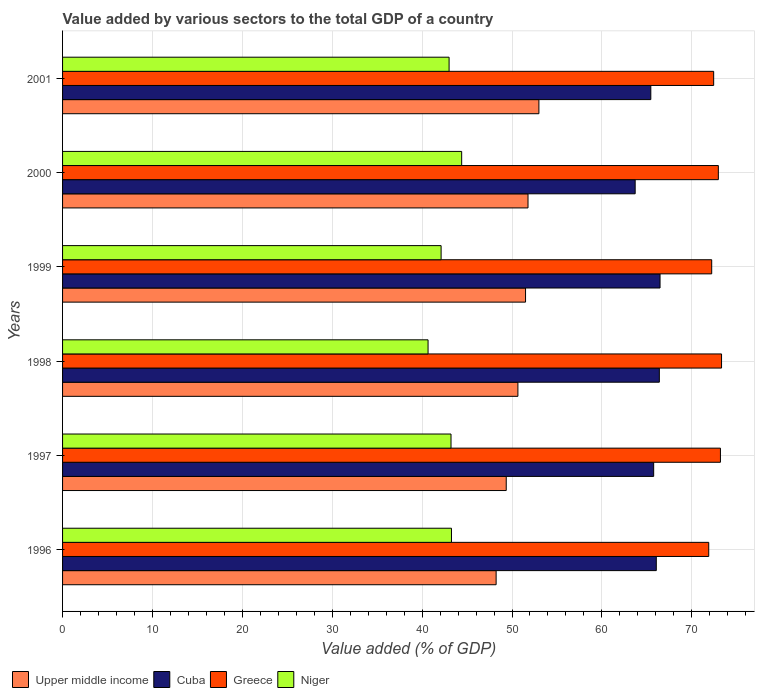How many different coloured bars are there?
Your answer should be compact. 4. Are the number of bars per tick equal to the number of legend labels?
Your answer should be compact. Yes. How many bars are there on the 1st tick from the top?
Your response must be concise. 4. How many bars are there on the 3rd tick from the bottom?
Offer a very short reply. 4. What is the label of the 1st group of bars from the top?
Ensure brevity in your answer.  2001. What is the value added by various sectors to the total GDP in Upper middle income in 1998?
Provide a short and direct response. 50.66. Across all years, what is the maximum value added by various sectors to the total GDP in Cuba?
Make the answer very short. 66.47. Across all years, what is the minimum value added by various sectors to the total GDP in Greece?
Your answer should be compact. 71.89. In which year was the value added by various sectors to the total GDP in Upper middle income minimum?
Give a very brief answer. 1996. What is the total value added by various sectors to the total GDP in Greece in the graph?
Your answer should be compact. 436. What is the difference between the value added by various sectors to the total GDP in Niger in 1998 and that in 2000?
Provide a short and direct response. -3.74. What is the difference between the value added by various sectors to the total GDP in Niger in 1997 and the value added by various sectors to the total GDP in Cuba in 1999?
Offer a terse response. -23.26. What is the average value added by various sectors to the total GDP in Cuba per year?
Your answer should be very brief. 65.64. In the year 1997, what is the difference between the value added by various sectors to the total GDP in Greece and value added by various sectors to the total GDP in Upper middle income?
Your response must be concise. 23.83. What is the ratio of the value added by various sectors to the total GDP in Greece in 1996 to that in 1999?
Ensure brevity in your answer.  1. What is the difference between the highest and the second highest value added by various sectors to the total GDP in Greece?
Keep it short and to the point. 0.12. What is the difference between the highest and the lowest value added by various sectors to the total GDP in Cuba?
Keep it short and to the point. 2.77. Is the sum of the value added by various sectors to the total GDP in Cuba in 1996 and 2001 greater than the maximum value added by various sectors to the total GDP in Niger across all years?
Keep it short and to the point. Yes. Is it the case that in every year, the sum of the value added by various sectors to the total GDP in Niger and value added by various sectors to the total GDP in Upper middle income is greater than the sum of value added by various sectors to the total GDP in Cuba and value added by various sectors to the total GDP in Greece?
Provide a succinct answer. No. What does the 3rd bar from the top in 2001 represents?
Give a very brief answer. Cuba. What does the 1st bar from the bottom in 1998 represents?
Keep it short and to the point. Upper middle income. Is it the case that in every year, the sum of the value added by various sectors to the total GDP in Cuba and value added by various sectors to the total GDP in Upper middle income is greater than the value added by various sectors to the total GDP in Niger?
Your response must be concise. Yes. How many bars are there?
Provide a short and direct response. 24. Does the graph contain grids?
Your response must be concise. Yes. Where does the legend appear in the graph?
Offer a terse response. Bottom left. How are the legend labels stacked?
Offer a terse response. Horizontal. What is the title of the graph?
Your response must be concise. Value added by various sectors to the total GDP of a country. What is the label or title of the X-axis?
Provide a succinct answer. Value added (% of GDP). What is the label or title of the Y-axis?
Offer a terse response. Years. What is the Value added (% of GDP) in Upper middle income in 1996?
Provide a succinct answer. 48.23. What is the Value added (% of GDP) of Cuba in 1996?
Provide a short and direct response. 66.05. What is the Value added (% of GDP) of Greece in 1996?
Provide a short and direct response. 71.89. What is the Value added (% of GDP) in Niger in 1996?
Your response must be concise. 43.27. What is the Value added (% of GDP) in Upper middle income in 1997?
Your response must be concise. 49.36. What is the Value added (% of GDP) of Cuba in 1997?
Offer a very short reply. 65.76. What is the Value added (% of GDP) in Greece in 1997?
Ensure brevity in your answer.  73.19. What is the Value added (% of GDP) of Niger in 1997?
Your answer should be very brief. 43.21. What is the Value added (% of GDP) in Upper middle income in 1998?
Keep it short and to the point. 50.66. What is the Value added (% of GDP) in Cuba in 1998?
Your answer should be compact. 66.39. What is the Value added (% of GDP) of Greece in 1998?
Ensure brevity in your answer.  73.31. What is the Value added (% of GDP) in Niger in 1998?
Give a very brief answer. 40.66. What is the Value added (% of GDP) in Upper middle income in 1999?
Provide a succinct answer. 51.51. What is the Value added (% of GDP) of Cuba in 1999?
Keep it short and to the point. 66.47. What is the Value added (% of GDP) in Greece in 1999?
Offer a very short reply. 72.22. What is the Value added (% of GDP) in Niger in 1999?
Provide a short and direct response. 42.11. What is the Value added (% of GDP) in Upper middle income in 2000?
Ensure brevity in your answer.  51.78. What is the Value added (% of GDP) of Cuba in 2000?
Give a very brief answer. 63.7. What is the Value added (% of GDP) in Greece in 2000?
Ensure brevity in your answer.  72.96. What is the Value added (% of GDP) of Niger in 2000?
Offer a very short reply. 44.4. What is the Value added (% of GDP) of Upper middle income in 2001?
Ensure brevity in your answer.  52.99. What is the Value added (% of GDP) in Cuba in 2001?
Provide a succinct answer. 65.44. What is the Value added (% of GDP) in Greece in 2001?
Provide a succinct answer. 72.44. What is the Value added (% of GDP) in Niger in 2001?
Ensure brevity in your answer.  43. Across all years, what is the maximum Value added (% of GDP) in Upper middle income?
Your response must be concise. 52.99. Across all years, what is the maximum Value added (% of GDP) of Cuba?
Give a very brief answer. 66.47. Across all years, what is the maximum Value added (% of GDP) of Greece?
Give a very brief answer. 73.31. Across all years, what is the maximum Value added (% of GDP) in Niger?
Provide a succinct answer. 44.4. Across all years, what is the minimum Value added (% of GDP) in Upper middle income?
Provide a short and direct response. 48.23. Across all years, what is the minimum Value added (% of GDP) in Cuba?
Make the answer very short. 63.7. Across all years, what is the minimum Value added (% of GDP) of Greece?
Keep it short and to the point. 71.89. Across all years, what is the minimum Value added (% of GDP) in Niger?
Your answer should be very brief. 40.66. What is the total Value added (% of GDP) in Upper middle income in the graph?
Provide a succinct answer. 304.53. What is the total Value added (% of GDP) in Cuba in the graph?
Your answer should be compact. 393.82. What is the total Value added (% of GDP) of Greece in the graph?
Provide a short and direct response. 436. What is the total Value added (% of GDP) in Niger in the graph?
Ensure brevity in your answer.  256.66. What is the difference between the Value added (% of GDP) of Upper middle income in 1996 and that in 1997?
Provide a succinct answer. -1.12. What is the difference between the Value added (% of GDP) of Cuba in 1996 and that in 1997?
Offer a very short reply. 0.29. What is the difference between the Value added (% of GDP) in Greece in 1996 and that in 1997?
Make the answer very short. -1.3. What is the difference between the Value added (% of GDP) in Niger in 1996 and that in 1997?
Ensure brevity in your answer.  0.05. What is the difference between the Value added (% of GDP) of Upper middle income in 1996 and that in 1998?
Your answer should be compact. -2.42. What is the difference between the Value added (% of GDP) of Cuba in 1996 and that in 1998?
Give a very brief answer. -0.34. What is the difference between the Value added (% of GDP) of Greece in 1996 and that in 1998?
Keep it short and to the point. -1.43. What is the difference between the Value added (% of GDP) in Niger in 1996 and that in 1998?
Make the answer very short. 2.6. What is the difference between the Value added (% of GDP) in Upper middle income in 1996 and that in 1999?
Give a very brief answer. -3.27. What is the difference between the Value added (% of GDP) in Cuba in 1996 and that in 1999?
Your answer should be compact. -0.42. What is the difference between the Value added (% of GDP) of Greece in 1996 and that in 1999?
Provide a succinct answer. -0.33. What is the difference between the Value added (% of GDP) in Niger in 1996 and that in 1999?
Offer a very short reply. 1.15. What is the difference between the Value added (% of GDP) of Upper middle income in 1996 and that in 2000?
Your answer should be very brief. -3.55. What is the difference between the Value added (% of GDP) of Cuba in 1996 and that in 2000?
Offer a very short reply. 2.35. What is the difference between the Value added (% of GDP) in Greece in 1996 and that in 2000?
Keep it short and to the point. -1.07. What is the difference between the Value added (% of GDP) of Niger in 1996 and that in 2000?
Keep it short and to the point. -1.13. What is the difference between the Value added (% of GDP) of Upper middle income in 1996 and that in 2001?
Your answer should be compact. -4.76. What is the difference between the Value added (% of GDP) in Cuba in 1996 and that in 2001?
Give a very brief answer. 0.61. What is the difference between the Value added (% of GDP) in Greece in 1996 and that in 2001?
Keep it short and to the point. -0.55. What is the difference between the Value added (% of GDP) in Niger in 1996 and that in 2001?
Give a very brief answer. 0.26. What is the difference between the Value added (% of GDP) of Upper middle income in 1997 and that in 1998?
Give a very brief answer. -1.3. What is the difference between the Value added (% of GDP) in Cuba in 1997 and that in 1998?
Offer a terse response. -0.63. What is the difference between the Value added (% of GDP) in Greece in 1997 and that in 1998?
Make the answer very short. -0.12. What is the difference between the Value added (% of GDP) in Niger in 1997 and that in 1998?
Offer a very short reply. 2.55. What is the difference between the Value added (% of GDP) of Upper middle income in 1997 and that in 1999?
Your answer should be compact. -2.15. What is the difference between the Value added (% of GDP) in Cuba in 1997 and that in 1999?
Offer a terse response. -0.71. What is the difference between the Value added (% of GDP) of Greece in 1997 and that in 1999?
Your response must be concise. 0.97. What is the difference between the Value added (% of GDP) in Niger in 1997 and that in 1999?
Ensure brevity in your answer.  1.1. What is the difference between the Value added (% of GDP) of Upper middle income in 1997 and that in 2000?
Keep it short and to the point. -2.42. What is the difference between the Value added (% of GDP) in Cuba in 1997 and that in 2000?
Ensure brevity in your answer.  2.06. What is the difference between the Value added (% of GDP) in Greece in 1997 and that in 2000?
Ensure brevity in your answer.  0.23. What is the difference between the Value added (% of GDP) in Niger in 1997 and that in 2000?
Give a very brief answer. -1.19. What is the difference between the Value added (% of GDP) of Upper middle income in 1997 and that in 2001?
Make the answer very short. -3.63. What is the difference between the Value added (% of GDP) in Cuba in 1997 and that in 2001?
Make the answer very short. 0.32. What is the difference between the Value added (% of GDP) of Greece in 1997 and that in 2001?
Ensure brevity in your answer.  0.75. What is the difference between the Value added (% of GDP) of Niger in 1997 and that in 2001?
Your answer should be very brief. 0.21. What is the difference between the Value added (% of GDP) of Upper middle income in 1998 and that in 1999?
Your response must be concise. -0.85. What is the difference between the Value added (% of GDP) in Cuba in 1998 and that in 1999?
Your response must be concise. -0.08. What is the difference between the Value added (% of GDP) in Greece in 1998 and that in 1999?
Give a very brief answer. 1.09. What is the difference between the Value added (% of GDP) of Niger in 1998 and that in 1999?
Make the answer very short. -1.45. What is the difference between the Value added (% of GDP) in Upper middle income in 1998 and that in 2000?
Make the answer very short. -1.13. What is the difference between the Value added (% of GDP) in Cuba in 1998 and that in 2000?
Provide a succinct answer. 2.69. What is the difference between the Value added (% of GDP) of Greece in 1998 and that in 2000?
Give a very brief answer. 0.36. What is the difference between the Value added (% of GDP) in Niger in 1998 and that in 2000?
Provide a succinct answer. -3.74. What is the difference between the Value added (% of GDP) in Upper middle income in 1998 and that in 2001?
Your answer should be very brief. -2.34. What is the difference between the Value added (% of GDP) of Cuba in 1998 and that in 2001?
Keep it short and to the point. 0.95. What is the difference between the Value added (% of GDP) in Greece in 1998 and that in 2001?
Your response must be concise. 0.88. What is the difference between the Value added (% of GDP) of Niger in 1998 and that in 2001?
Offer a terse response. -2.34. What is the difference between the Value added (% of GDP) of Upper middle income in 1999 and that in 2000?
Offer a very short reply. -0.27. What is the difference between the Value added (% of GDP) of Cuba in 1999 and that in 2000?
Keep it short and to the point. 2.77. What is the difference between the Value added (% of GDP) of Greece in 1999 and that in 2000?
Your answer should be very brief. -0.74. What is the difference between the Value added (% of GDP) in Niger in 1999 and that in 2000?
Offer a very short reply. -2.29. What is the difference between the Value added (% of GDP) of Upper middle income in 1999 and that in 2001?
Keep it short and to the point. -1.48. What is the difference between the Value added (% of GDP) of Cuba in 1999 and that in 2001?
Offer a terse response. 1.03. What is the difference between the Value added (% of GDP) in Greece in 1999 and that in 2001?
Your answer should be compact. -0.22. What is the difference between the Value added (% of GDP) of Niger in 1999 and that in 2001?
Make the answer very short. -0.89. What is the difference between the Value added (% of GDP) of Upper middle income in 2000 and that in 2001?
Offer a terse response. -1.21. What is the difference between the Value added (% of GDP) in Cuba in 2000 and that in 2001?
Keep it short and to the point. -1.74. What is the difference between the Value added (% of GDP) in Greece in 2000 and that in 2001?
Provide a short and direct response. 0.52. What is the difference between the Value added (% of GDP) in Niger in 2000 and that in 2001?
Your answer should be very brief. 1.4. What is the difference between the Value added (% of GDP) of Upper middle income in 1996 and the Value added (% of GDP) of Cuba in 1997?
Ensure brevity in your answer.  -17.53. What is the difference between the Value added (% of GDP) of Upper middle income in 1996 and the Value added (% of GDP) of Greece in 1997?
Give a very brief answer. -24.95. What is the difference between the Value added (% of GDP) of Upper middle income in 1996 and the Value added (% of GDP) of Niger in 1997?
Make the answer very short. 5.02. What is the difference between the Value added (% of GDP) of Cuba in 1996 and the Value added (% of GDP) of Greece in 1997?
Offer a terse response. -7.14. What is the difference between the Value added (% of GDP) of Cuba in 1996 and the Value added (% of GDP) of Niger in 1997?
Offer a terse response. 22.84. What is the difference between the Value added (% of GDP) in Greece in 1996 and the Value added (% of GDP) in Niger in 1997?
Keep it short and to the point. 28.67. What is the difference between the Value added (% of GDP) of Upper middle income in 1996 and the Value added (% of GDP) of Cuba in 1998?
Ensure brevity in your answer.  -18.16. What is the difference between the Value added (% of GDP) in Upper middle income in 1996 and the Value added (% of GDP) in Greece in 1998?
Ensure brevity in your answer.  -25.08. What is the difference between the Value added (% of GDP) of Upper middle income in 1996 and the Value added (% of GDP) of Niger in 1998?
Make the answer very short. 7.57. What is the difference between the Value added (% of GDP) of Cuba in 1996 and the Value added (% of GDP) of Greece in 1998?
Give a very brief answer. -7.26. What is the difference between the Value added (% of GDP) of Cuba in 1996 and the Value added (% of GDP) of Niger in 1998?
Ensure brevity in your answer.  25.39. What is the difference between the Value added (% of GDP) in Greece in 1996 and the Value added (% of GDP) in Niger in 1998?
Make the answer very short. 31.23. What is the difference between the Value added (% of GDP) in Upper middle income in 1996 and the Value added (% of GDP) in Cuba in 1999?
Give a very brief answer. -18.24. What is the difference between the Value added (% of GDP) of Upper middle income in 1996 and the Value added (% of GDP) of Greece in 1999?
Provide a short and direct response. -23.98. What is the difference between the Value added (% of GDP) in Upper middle income in 1996 and the Value added (% of GDP) in Niger in 1999?
Provide a succinct answer. 6.12. What is the difference between the Value added (% of GDP) in Cuba in 1996 and the Value added (% of GDP) in Greece in 1999?
Give a very brief answer. -6.17. What is the difference between the Value added (% of GDP) in Cuba in 1996 and the Value added (% of GDP) in Niger in 1999?
Offer a terse response. 23.94. What is the difference between the Value added (% of GDP) of Greece in 1996 and the Value added (% of GDP) of Niger in 1999?
Provide a short and direct response. 29.77. What is the difference between the Value added (% of GDP) of Upper middle income in 1996 and the Value added (% of GDP) of Cuba in 2000?
Provide a short and direct response. -15.47. What is the difference between the Value added (% of GDP) in Upper middle income in 1996 and the Value added (% of GDP) in Greece in 2000?
Offer a very short reply. -24.72. What is the difference between the Value added (% of GDP) of Upper middle income in 1996 and the Value added (% of GDP) of Niger in 2000?
Give a very brief answer. 3.83. What is the difference between the Value added (% of GDP) of Cuba in 1996 and the Value added (% of GDP) of Greece in 2000?
Keep it short and to the point. -6.9. What is the difference between the Value added (% of GDP) of Cuba in 1996 and the Value added (% of GDP) of Niger in 2000?
Your response must be concise. 21.65. What is the difference between the Value added (% of GDP) of Greece in 1996 and the Value added (% of GDP) of Niger in 2000?
Provide a succinct answer. 27.49. What is the difference between the Value added (% of GDP) in Upper middle income in 1996 and the Value added (% of GDP) in Cuba in 2001?
Keep it short and to the point. -17.21. What is the difference between the Value added (% of GDP) in Upper middle income in 1996 and the Value added (% of GDP) in Greece in 2001?
Give a very brief answer. -24.2. What is the difference between the Value added (% of GDP) of Upper middle income in 1996 and the Value added (% of GDP) of Niger in 2001?
Your response must be concise. 5.23. What is the difference between the Value added (% of GDP) in Cuba in 1996 and the Value added (% of GDP) in Greece in 2001?
Ensure brevity in your answer.  -6.38. What is the difference between the Value added (% of GDP) in Cuba in 1996 and the Value added (% of GDP) in Niger in 2001?
Give a very brief answer. 23.05. What is the difference between the Value added (% of GDP) in Greece in 1996 and the Value added (% of GDP) in Niger in 2001?
Keep it short and to the point. 28.89. What is the difference between the Value added (% of GDP) in Upper middle income in 1997 and the Value added (% of GDP) in Cuba in 1998?
Keep it short and to the point. -17.03. What is the difference between the Value added (% of GDP) in Upper middle income in 1997 and the Value added (% of GDP) in Greece in 1998?
Make the answer very short. -23.95. What is the difference between the Value added (% of GDP) in Upper middle income in 1997 and the Value added (% of GDP) in Niger in 1998?
Offer a very short reply. 8.7. What is the difference between the Value added (% of GDP) of Cuba in 1997 and the Value added (% of GDP) of Greece in 1998?
Ensure brevity in your answer.  -7.55. What is the difference between the Value added (% of GDP) of Cuba in 1997 and the Value added (% of GDP) of Niger in 1998?
Keep it short and to the point. 25.1. What is the difference between the Value added (% of GDP) of Greece in 1997 and the Value added (% of GDP) of Niger in 1998?
Your response must be concise. 32.53. What is the difference between the Value added (% of GDP) in Upper middle income in 1997 and the Value added (% of GDP) in Cuba in 1999?
Your response must be concise. -17.11. What is the difference between the Value added (% of GDP) in Upper middle income in 1997 and the Value added (% of GDP) in Greece in 1999?
Provide a succinct answer. -22.86. What is the difference between the Value added (% of GDP) of Upper middle income in 1997 and the Value added (% of GDP) of Niger in 1999?
Ensure brevity in your answer.  7.25. What is the difference between the Value added (% of GDP) in Cuba in 1997 and the Value added (% of GDP) in Greece in 1999?
Provide a short and direct response. -6.46. What is the difference between the Value added (% of GDP) in Cuba in 1997 and the Value added (% of GDP) in Niger in 1999?
Your answer should be very brief. 23.65. What is the difference between the Value added (% of GDP) of Greece in 1997 and the Value added (% of GDP) of Niger in 1999?
Ensure brevity in your answer.  31.08. What is the difference between the Value added (% of GDP) in Upper middle income in 1997 and the Value added (% of GDP) in Cuba in 2000?
Provide a short and direct response. -14.34. What is the difference between the Value added (% of GDP) in Upper middle income in 1997 and the Value added (% of GDP) in Greece in 2000?
Offer a very short reply. -23.6. What is the difference between the Value added (% of GDP) of Upper middle income in 1997 and the Value added (% of GDP) of Niger in 2000?
Provide a succinct answer. 4.96. What is the difference between the Value added (% of GDP) of Cuba in 1997 and the Value added (% of GDP) of Greece in 2000?
Offer a terse response. -7.2. What is the difference between the Value added (% of GDP) of Cuba in 1997 and the Value added (% of GDP) of Niger in 2000?
Make the answer very short. 21.36. What is the difference between the Value added (% of GDP) in Greece in 1997 and the Value added (% of GDP) in Niger in 2000?
Give a very brief answer. 28.79. What is the difference between the Value added (% of GDP) in Upper middle income in 1997 and the Value added (% of GDP) in Cuba in 2001?
Your response must be concise. -16.08. What is the difference between the Value added (% of GDP) in Upper middle income in 1997 and the Value added (% of GDP) in Greece in 2001?
Keep it short and to the point. -23.08. What is the difference between the Value added (% of GDP) in Upper middle income in 1997 and the Value added (% of GDP) in Niger in 2001?
Offer a terse response. 6.36. What is the difference between the Value added (% of GDP) of Cuba in 1997 and the Value added (% of GDP) of Greece in 2001?
Your answer should be compact. -6.67. What is the difference between the Value added (% of GDP) in Cuba in 1997 and the Value added (% of GDP) in Niger in 2001?
Your response must be concise. 22.76. What is the difference between the Value added (% of GDP) of Greece in 1997 and the Value added (% of GDP) of Niger in 2001?
Provide a short and direct response. 30.19. What is the difference between the Value added (% of GDP) of Upper middle income in 1998 and the Value added (% of GDP) of Cuba in 1999?
Keep it short and to the point. -15.81. What is the difference between the Value added (% of GDP) in Upper middle income in 1998 and the Value added (% of GDP) in Greece in 1999?
Give a very brief answer. -21.56. What is the difference between the Value added (% of GDP) in Upper middle income in 1998 and the Value added (% of GDP) in Niger in 1999?
Keep it short and to the point. 8.54. What is the difference between the Value added (% of GDP) in Cuba in 1998 and the Value added (% of GDP) in Greece in 1999?
Give a very brief answer. -5.83. What is the difference between the Value added (% of GDP) of Cuba in 1998 and the Value added (% of GDP) of Niger in 1999?
Keep it short and to the point. 24.28. What is the difference between the Value added (% of GDP) of Greece in 1998 and the Value added (% of GDP) of Niger in 1999?
Make the answer very short. 31.2. What is the difference between the Value added (% of GDP) of Upper middle income in 1998 and the Value added (% of GDP) of Cuba in 2000?
Offer a terse response. -13.05. What is the difference between the Value added (% of GDP) in Upper middle income in 1998 and the Value added (% of GDP) in Greece in 2000?
Provide a succinct answer. -22.3. What is the difference between the Value added (% of GDP) in Upper middle income in 1998 and the Value added (% of GDP) in Niger in 2000?
Keep it short and to the point. 6.26. What is the difference between the Value added (% of GDP) in Cuba in 1998 and the Value added (% of GDP) in Greece in 2000?
Provide a short and direct response. -6.56. What is the difference between the Value added (% of GDP) of Cuba in 1998 and the Value added (% of GDP) of Niger in 2000?
Offer a very short reply. 21.99. What is the difference between the Value added (% of GDP) in Greece in 1998 and the Value added (% of GDP) in Niger in 2000?
Your answer should be very brief. 28.91. What is the difference between the Value added (% of GDP) of Upper middle income in 1998 and the Value added (% of GDP) of Cuba in 2001?
Offer a terse response. -14.79. What is the difference between the Value added (% of GDP) of Upper middle income in 1998 and the Value added (% of GDP) of Greece in 2001?
Make the answer very short. -21.78. What is the difference between the Value added (% of GDP) of Upper middle income in 1998 and the Value added (% of GDP) of Niger in 2001?
Give a very brief answer. 7.66. What is the difference between the Value added (% of GDP) of Cuba in 1998 and the Value added (% of GDP) of Greece in 2001?
Ensure brevity in your answer.  -6.04. What is the difference between the Value added (% of GDP) in Cuba in 1998 and the Value added (% of GDP) in Niger in 2001?
Ensure brevity in your answer.  23.39. What is the difference between the Value added (% of GDP) in Greece in 1998 and the Value added (% of GDP) in Niger in 2001?
Keep it short and to the point. 30.31. What is the difference between the Value added (% of GDP) in Upper middle income in 1999 and the Value added (% of GDP) in Cuba in 2000?
Provide a succinct answer. -12.19. What is the difference between the Value added (% of GDP) of Upper middle income in 1999 and the Value added (% of GDP) of Greece in 2000?
Ensure brevity in your answer.  -21.45. What is the difference between the Value added (% of GDP) of Upper middle income in 1999 and the Value added (% of GDP) of Niger in 2000?
Give a very brief answer. 7.11. What is the difference between the Value added (% of GDP) of Cuba in 1999 and the Value added (% of GDP) of Greece in 2000?
Offer a very short reply. -6.49. What is the difference between the Value added (% of GDP) in Cuba in 1999 and the Value added (% of GDP) in Niger in 2000?
Provide a short and direct response. 22.07. What is the difference between the Value added (% of GDP) of Greece in 1999 and the Value added (% of GDP) of Niger in 2000?
Ensure brevity in your answer.  27.82. What is the difference between the Value added (% of GDP) in Upper middle income in 1999 and the Value added (% of GDP) in Cuba in 2001?
Make the answer very short. -13.94. What is the difference between the Value added (% of GDP) in Upper middle income in 1999 and the Value added (% of GDP) in Greece in 2001?
Your response must be concise. -20.93. What is the difference between the Value added (% of GDP) in Upper middle income in 1999 and the Value added (% of GDP) in Niger in 2001?
Provide a succinct answer. 8.51. What is the difference between the Value added (% of GDP) in Cuba in 1999 and the Value added (% of GDP) in Greece in 2001?
Your answer should be very brief. -5.97. What is the difference between the Value added (% of GDP) in Cuba in 1999 and the Value added (% of GDP) in Niger in 2001?
Your answer should be very brief. 23.47. What is the difference between the Value added (% of GDP) in Greece in 1999 and the Value added (% of GDP) in Niger in 2001?
Offer a terse response. 29.22. What is the difference between the Value added (% of GDP) in Upper middle income in 2000 and the Value added (% of GDP) in Cuba in 2001?
Make the answer very short. -13.66. What is the difference between the Value added (% of GDP) in Upper middle income in 2000 and the Value added (% of GDP) in Greece in 2001?
Your answer should be compact. -20.65. What is the difference between the Value added (% of GDP) of Upper middle income in 2000 and the Value added (% of GDP) of Niger in 2001?
Provide a short and direct response. 8.78. What is the difference between the Value added (% of GDP) of Cuba in 2000 and the Value added (% of GDP) of Greece in 2001?
Offer a terse response. -8.73. What is the difference between the Value added (% of GDP) of Cuba in 2000 and the Value added (% of GDP) of Niger in 2001?
Ensure brevity in your answer.  20.7. What is the difference between the Value added (% of GDP) in Greece in 2000 and the Value added (% of GDP) in Niger in 2001?
Your response must be concise. 29.95. What is the average Value added (% of GDP) of Upper middle income per year?
Provide a short and direct response. 50.76. What is the average Value added (% of GDP) in Cuba per year?
Your response must be concise. 65.64. What is the average Value added (% of GDP) in Greece per year?
Keep it short and to the point. 72.67. What is the average Value added (% of GDP) in Niger per year?
Your answer should be very brief. 42.78. In the year 1996, what is the difference between the Value added (% of GDP) in Upper middle income and Value added (% of GDP) in Cuba?
Your response must be concise. -17.82. In the year 1996, what is the difference between the Value added (% of GDP) in Upper middle income and Value added (% of GDP) in Greece?
Provide a short and direct response. -23.65. In the year 1996, what is the difference between the Value added (% of GDP) in Upper middle income and Value added (% of GDP) in Niger?
Provide a succinct answer. 4.97. In the year 1996, what is the difference between the Value added (% of GDP) of Cuba and Value added (% of GDP) of Greece?
Your response must be concise. -5.83. In the year 1996, what is the difference between the Value added (% of GDP) of Cuba and Value added (% of GDP) of Niger?
Ensure brevity in your answer.  22.79. In the year 1996, what is the difference between the Value added (% of GDP) of Greece and Value added (% of GDP) of Niger?
Ensure brevity in your answer.  28.62. In the year 1997, what is the difference between the Value added (% of GDP) in Upper middle income and Value added (% of GDP) in Cuba?
Ensure brevity in your answer.  -16.4. In the year 1997, what is the difference between the Value added (% of GDP) in Upper middle income and Value added (% of GDP) in Greece?
Ensure brevity in your answer.  -23.83. In the year 1997, what is the difference between the Value added (% of GDP) in Upper middle income and Value added (% of GDP) in Niger?
Ensure brevity in your answer.  6.14. In the year 1997, what is the difference between the Value added (% of GDP) in Cuba and Value added (% of GDP) in Greece?
Your answer should be very brief. -7.43. In the year 1997, what is the difference between the Value added (% of GDP) in Cuba and Value added (% of GDP) in Niger?
Offer a very short reply. 22.55. In the year 1997, what is the difference between the Value added (% of GDP) in Greece and Value added (% of GDP) in Niger?
Provide a succinct answer. 29.97. In the year 1998, what is the difference between the Value added (% of GDP) of Upper middle income and Value added (% of GDP) of Cuba?
Make the answer very short. -15.74. In the year 1998, what is the difference between the Value added (% of GDP) of Upper middle income and Value added (% of GDP) of Greece?
Give a very brief answer. -22.66. In the year 1998, what is the difference between the Value added (% of GDP) in Upper middle income and Value added (% of GDP) in Niger?
Offer a terse response. 10. In the year 1998, what is the difference between the Value added (% of GDP) in Cuba and Value added (% of GDP) in Greece?
Give a very brief answer. -6.92. In the year 1998, what is the difference between the Value added (% of GDP) in Cuba and Value added (% of GDP) in Niger?
Provide a short and direct response. 25.73. In the year 1998, what is the difference between the Value added (% of GDP) of Greece and Value added (% of GDP) of Niger?
Give a very brief answer. 32.65. In the year 1999, what is the difference between the Value added (% of GDP) of Upper middle income and Value added (% of GDP) of Cuba?
Provide a succinct answer. -14.96. In the year 1999, what is the difference between the Value added (% of GDP) in Upper middle income and Value added (% of GDP) in Greece?
Make the answer very short. -20.71. In the year 1999, what is the difference between the Value added (% of GDP) of Upper middle income and Value added (% of GDP) of Niger?
Give a very brief answer. 9.39. In the year 1999, what is the difference between the Value added (% of GDP) of Cuba and Value added (% of GDP) of Greece?
Your answer should be compact. -5.75. In the year 1999, what is the difference between the Value added (% of GDP) in Cuba and Value added (% of GDP) in Niger?
Provide a succinct answer. 24.36. In the year 1999, what is the difference between the Value added (% of GDP) of Greece and Value added (% of GDP) of Niger?
Your response must be concise. 30.1. In the year 2000, what is the difference between the Value added (% of GDP) in Upper middle income and Value added (% of GDP) in Cuba?
Offer a terse response. -11.92. In the year 2000, what is the difference between the Value added (% of GDP) in Upper middle income and Value added (% of GDP) in Greece?
Your response must be concise. -21.17. In the year 2000, what is the difference between the Value added (% of GDP) of Upper middle income and Value added (% of GDP) of Niger?
Keep it short and to the point. 7.38. In the year 2000, what is the difference between the Value added (% of GDP) of Cuba and Value added (% of GDP) of Greece?
Ensure brevity in your answer.  -9.25. In the year 2000, what is the difference between the Value added (% of GDP) of Cuba and Value added (% of GDP) of Niger?
Your answer should be very brief. 19.3. In the year 2000, what is the difference between the Value added (% of GDP) in Greece and Value added (% of GDP) in Niger?
Your answer should be very brief. 28.56. In the year 2001, what is the difference between the Value added (% of GDP) in Upper middle income and Value added (% of GDP) in Cuba?
Make the answer very short. -12.45. In the year 2001, what is the difference between the Value added (% of GDP) in Upper middle income and Value added (% of GDP) in Greece?
Offer a very short reply. -19.44. In the year 2001, what is the difference between the Value added (% of GDP) in Upper middle income and Value added (% of GDP) in Niger?
Offer a very short reply. 9.99. In the year 2001, what is the difference between the Value added (% of GDP) of Cuba and Value added (% of GDP) of Greece?
Ensure brevity in your answer.  -6.99. In the year 2001, what is the difference between the Value added (% of GDP) of Cuba and Value added (% of GDP) of Niger?
Give a very brief answer. 22.44. In the year 2001, what is the difference between the Value added (% of GDP) in Greece and Value added (% of GDP) in Niger?
Provide a short and direct response. 29.43. What is the ratio of the Value added (% of GDP) of Upper middle income in 1996 to that in 1997?
Your response must be concise. 0.98. What is the ratio of the Value added (% of GDP) of Greece in 1996 to that in 1997?
Your answer should be compact. 0.98. What is the ratio of the Value added (% of GDP) in Upper middle income in 1996 to that in 1998?
Your response must be concise. 0.95. What is the ratio of the Value added (% of GDP) of Cuba in 1996 to that in 1998?
Offer a very short reply. 0.99. What is the ratio of the Value added (% of GDP) of Greece in 1996 to that in 1998?
Your answer should be compact. 0.98. What is the ratio of the Value added (% of GDP) of Niger in 1996 to that in 1998?
Give a very brief answer. 1.06. What is the ratio of the Value added (% of GDP) in Upper middle income in 1996 to that in 1999?
Give a very brief answer. 0.94. What is the ratio of the Value added (% of GDP) of Greece in 1996 to that in 1999?
Keep it short and to the point. 1. What is the ratio of the Value added (% of GDP) in Niger in 1996 to that in 1999?
Offer a terse response. 1.03. What is the ratio of the Value added (% of GDP) in Upper middle income in 1996 to that in 2000?
Your answer should be very brief. 0.93. What is the ratio of the Value added (% of GDP) in Cuba in 1996 to that in 2000?
Provide a succinct answer. 1.04. What is the ratio of the Value added (% of GDP) of Greece in 1996 to that in 2000?
Offer a terse response. 0.99. What is the ratio of the Value added (% of GDP) in Niger in 1996 to that in 2000?
Your answer should be very brief. 0.97. What is the ratio of the Value added (% of GDP) of Upper middle income in 1996 to that in 2001?
Provide a succinct answer. 0.91. What is the ratio of the Value added (% of GDP) in Cuba in 1996 to that in 2001?
Offer a very short reply. 1.01. What is the ratio of the Value added (% of GDP) in Niger in 1996 to that in 2001?
Your response must be concise. 1.01. What is the ratio of the Value added (% of GDP) in Upper middle income in 1997 to that in 1998?
Offer a very short reply. 0.97. What is the ratio of the Value added (% of GDP) of Greece in 1997 to that in 1998?
Give a very brief answer. 1. What is the ratio of the Value added (% of GDP) of Niger in 1997 to that in 1998?
Your answer should be very brief. 1.06. What is the ratio of the Value added (% of GDP) of Cuba in 1997 to that in 1999?
Your answer should be very brief. 0.99. What is the ratio of the Value added (% of GDP) in Greece in 1997 to that in 1999?
Keep it short and to the point. 1.01. What is the ratio of the Value added (% of GDP) of Niger in 1997 to that in 1999?
Make the answer very short. 1.03. What is the ratio of the Value added (% of GDP) in Upper middle income in 1997 to that in 2000?
Keep it short and to the point. 0.95. What is the ratio of the Value added (% of GDP) of Cuba in 1997 to that in 2000?
Keep it short and to the point. 1.03. What is the ratio of the Value added (% of GDP) in Greece in 1997 to that in 2000?
Provide a succinct answer. 1. What is the ratio of the Value added (% of GDP) of Niger in 1997 to that in 2000?
Provide a short and direct response. 0.97. What is the ratio of the Value added (% of GDP) of Upper middle income in 1997 to that in 2001?
Your response must be concise. 0.93. What is the ratio of the Value added (% of GDP) of Cuba in 1997 to that in 2001?
Give a very brief answer. 1. What is the ratio of the Value added (% of GDP) in Greece in 1997 to that in 2001?
Your answer should be compact. 1.01. What is the ratio of the Value added (% of GDP) in Niger in 1997 to that in 2001?
Your answer should be compact. 1. What is the ratio of the Value added (% of GDP) in Upper middle income in 1998 to that in 1999?
Make the answer very short. 0.98. What is the ratio of the Value added (% of GDP) of Cuba in 1998 to that in 1999?
Your answer should be compact. 1. What is the ratio of the Value added (% of GDP) in Greece in 1998 to that in 1999?
Provide a succinct answer. 1.02. What is the ratio of the Value added (% of GDP) of Niger in 1998 to that in 1999?
Your response must be concise. 0.97. What is the ratio of the Value added (% of GDP) of Upper middle income in 1998 to that in 2000?
Give a very brief answer. 0.98. What is the ratio of the Value added (% of GDP) of Cuba in 1998 to that in 2000?
Give a very brief answer. 1.04. What is the ratio of the Value added (% of GDP) of Greece in 1998 to that in 2000?
Provide a succinct answer. 1. What is the ratio of the Value added (% of GDP) of Niger in 1998 to that in 2000?
Your answer should be very brief. 0.92. What is the ratio of the Value added (% of GDP) of Upper middle income in 1998 to that in 2001?
Provide a short and direct response. 0.96. What is the ratio of the Value added (% of GDP) of Cuba in 1998 to that in 2001?
Your answer should be very brief. 1.01. What is the ratio of the Value added (% of GDP) in Greece in 1998 to that in 2001?
Your answer should be very brief. 1.01. What is the ratio of the Value added (% of GDP) in Niger in 1998 to that in 2001?
Your response must be concise. 0.95. What is the ratio of the Value added (% of GDP) of Cuba in 1999 to that in 2000?
Offer a very short reply. 1.04. What is the ratio of the Value added (% of GDP) in Greece in 1999 to that in 2000?
Your answer should be very brief. 0.99. What is the ratio of the Value added (% of GDP) in Niger in 1999 to that in 2000?
Provide a short and direct response. 0.95. What is the ratio of the Value added (% of GDP) of Upper middle income in 1999 to that in 2001?
Keep it short and to the point. 0.97. What is the ratio of the Value added (% of GDP) in Cuba in 1999 to that in 2001?
Make the answer very short. 1.02. What is the ratio of the Value added (% of GDP) of Greece in 1999 to that in 2001?
Provide a short and direct response. 1. What is the ratio of the Value added (% of GDP) in Niger in 1999 to that in 2001?
Provide a short and direct response. 0.98. What is the ratio of the Value added (% of GDP) of Upper middle income in 2000 to that in 2001?
Provide a succinct answer. 0.98. What is the ratio of the Value added (% of GDP) of Cuba in 2000 to that in 2001?
Make the answer very short. 0.97. What is the ratio of the Value added (% of GDP) in Niger in 2000 to that in 2001?
Provide a short and direct response. 1.03. What is the difference between the highest and the second highest Value added (% of GDP) of Upper middle income?
Your response must be concise. 1.21. What is the difference between the highest and the second highest Value added (% of GDP) in Cuba?
Give a very brief answer. 0.08. What is the difference between the highest and the second highest Value added (% of GDP) of Greece?
Give a very brief answer. 0.12. What is the difference between the highest and the second highest Value added (% of GDP) in Niger?
Provide a succinct answer. 1.13. What is the difference between the highest and the lowest Value added (% of GDP) of Upper middle income?
Ensure brevity in your answer.  4.76. What is the difference between the highest and the lowest Value added (% of GDP) of Cuba?
Your answer should be compact. 2.77. What is the difference between the highest and the lowest Value added (% of GDP) in Greece?
Provide a short and direct response. 1.43. What is the difference between the highest and the lowest Value added (% of GDP) in Niger?
Offer a very short reply. 3.74. 